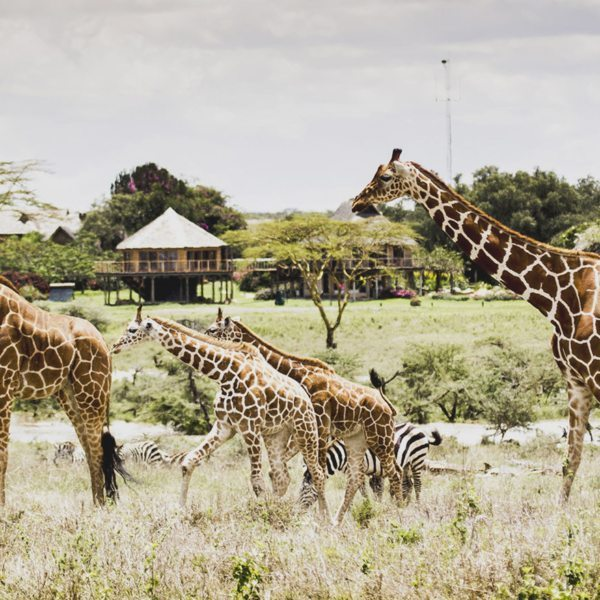In a parallel universe, how might this scene differ if the giraffes were the dominant species and built their own structures? In a parallel universe where giraffes are the dominant species and architects of their environment, the landscape might be dotted with towering structures resembling baobab trees, allowing them to utilize their height advantage to build expansive, elevated platforms. These giraffian constructions would feature intricately designed feeding stations at the tallest points, lush with foliage sourced from their favorite acacia trees. Giraffe families would live in multi-level sky dwellings, interconnected by vine-like bridges. Community spaces would exist at various heights to accommodate different family groups, and water conservation systems would be ingeniously placed at various levels to ensure a steady supply during the dry seasons. The savanna, while retaining much of its natural beauty, would have an extraordinary skyline influenced by the architectural prowess of its towering inhabitants, seamlessly blending function and the intrinsic elegance of giraffes into a dreamlike habitat. 